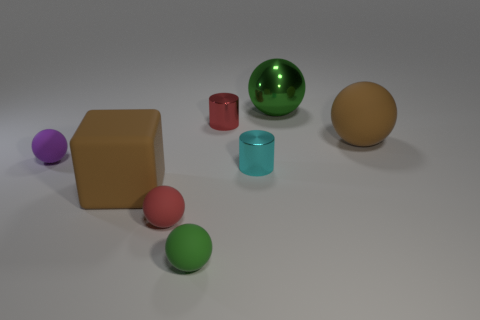What shape is the small matte object that is the same color as the metal ball?
Your answer should be compact. Sphere. What is the color of the matte thing that is the same size as the cube?
Provide a succinct answer. Brown. Are there any other big balls of the same color as the shiny ball?
Provide a short and direct response. No. Is the shape of the big brown matte object in front of the tiny cyan thing the same as the large brown rubber thing that is behind the cube?
Make the answer very short. No. There is a object that is the same color as the matte block; what size is it?
Keep it short and to the point. Large. How many other things are the same size as the red matte thing?
Your response must be concise. 4. There is a big matte cube; does it have the same color as the small matte ball in front of the small red sphere?
Provide a succinct answer. No. Are there fewer big shiny spheres in front of the small red matte object than brown rubber things that are right of the large brown ball?
Your response must be concise. No. What color is the big object that is to the right of the large brown block and in front of the red metal cylinder?
Make the answer very short. Brown. Do the red shiny cylinder and the green object behind the green rubber sphere have the same size?
Your answer should be compact. No. 